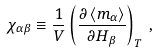Convert formula to latex. <formula><loc_0><loc_0><loc_500><loc_500>\chi _ { \alpha \beta } \equiv \frac { 1 } { V } \left ( \frac { \partial \left < m _ { \alpha } \right > } { \partial H _ { \beta } } \right ) _ { T } \, ,</formula> 